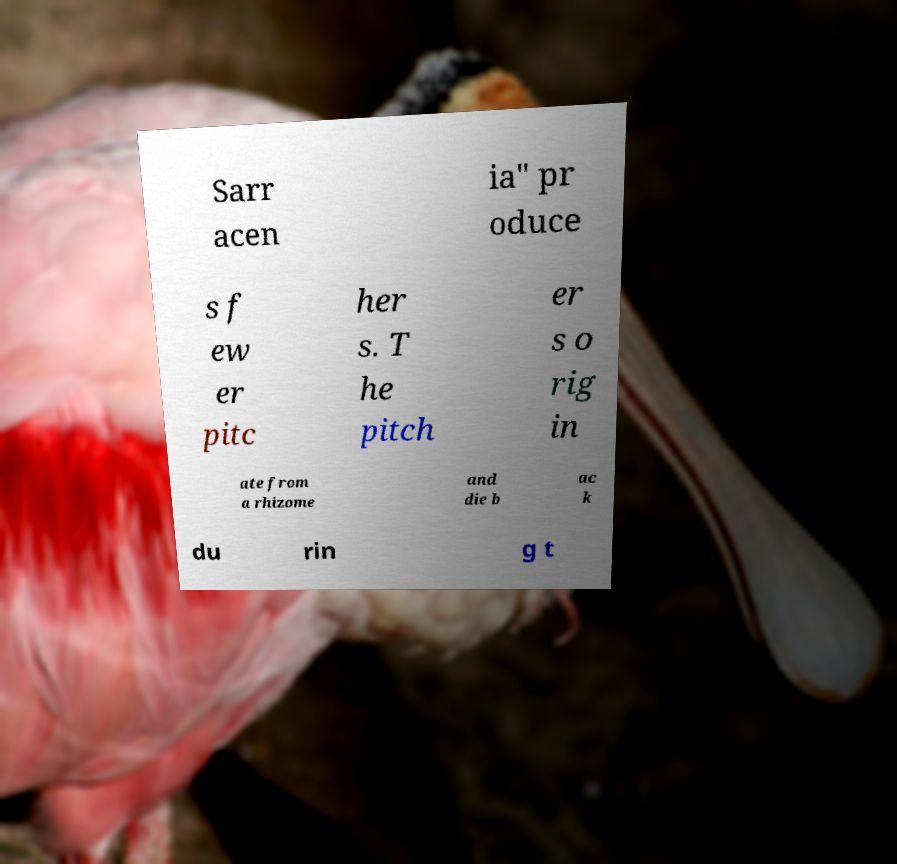Please identify and transcribe the text found in this image. Sarr acen ia" pr oduce s f ew er pitc her s. T he pitch er s o rig in ate from a rhizome and die b ac k du rin g t 